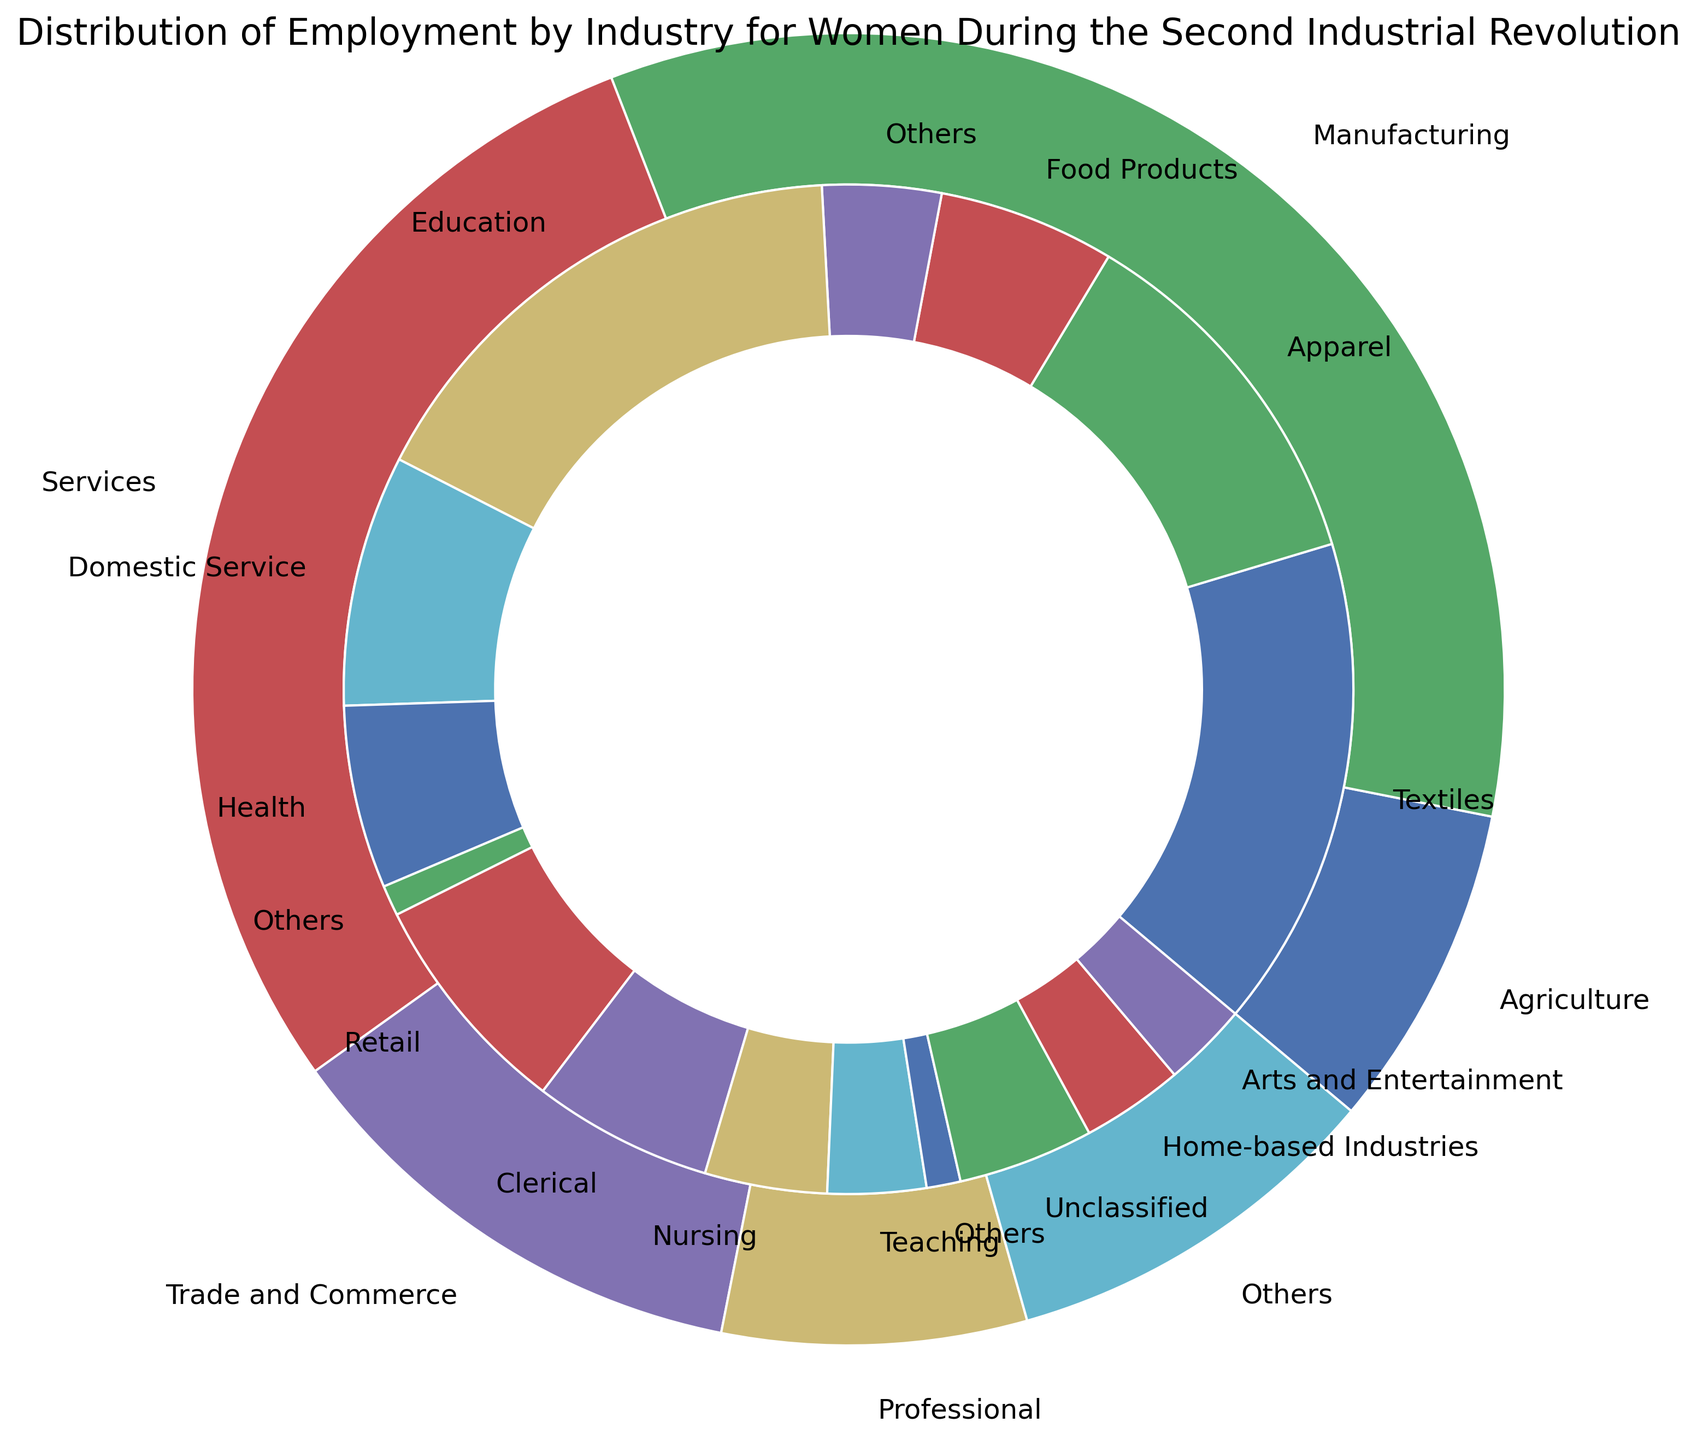What percentage of women were employed in the Services industry? The Services sector is represented as a main part of the outer pie segment, and its label indicates a 29% share of employment.
Answer: 29% Which sub-industry within Manufacturing employs the highest percentage of women? The sub-industries within Manufacturing are represented in the inner pie segment. Among Textiles, Apparel, Food Products, and Others, Textiles has the highest percentage of 14.5%.
Answer: Textiles What is the combined percentage of women employed in the Education and Health sub-industries within Services? From the inner pie segment, Education employs 15.3% and Health employs 5.4%. Adding these percentages gives 15.3 + 5.4 = 20.7%.
Answer: 20.7% Which has a higher percentage of employment, Agriculture or Trade and Commerce? Both Agriculture and Trade and Commerce are main industries shown in the outer pie. Agriculture has 8% while Trade and Commerce has 12%. Therefore, Trade and Commerce has a higher percentage.
Answer: Trade and Commerce What is the total percentage of women employed in the Manufacturing sub-industries, excluding 'Others'? The sub-industries of Manufacturing are Textiles (14.5%), Apparel (10.8%), and Food Products (5.2%). The total is 14.5 + 10.8 + 5.2 = 30.5%.
Answer: 30.5% How does the percentage of women in Domestic Service compare to that in Nursing? Domestic Service within the Services sector employs 7.4%, and Nursing within the Professional sector employs 3.6%. Domestic Service has a higher percentage.
Answer: Domestic Service has a higher percentage Which main industry employs more women, Professional or Others? The outer pie shows the percentage for Professional (7.5%) and Others (9.5%). Others employs more women.
Answer: Others What percentage of employment is attributed to sub-industries within Trade and Commerce? The sub-industries within Trade and Commerce are Retail (6.7%) and Clerical (5.3%). Adding these percentages gives 6.7 + 5.3 = 12%.
Answer: 12% What is the difference in percentage between women employed in Home-based Industries and Arts and Entertainment? Home-based Industries within Others has 3.0%, and Arts and Entertainment within Others has 2.5%. The difference is 3.0 - 2.5 = 0.5%.
Answer: 0.5% How many sub-industries have a higher percentage of employment than Agriculture? Agriculture employs 8%. The sub-industries with higher percentages are Textiles (14.5%), Apparel (10.8%), and Education (15.3%). Hence, there are three sub-industries.
Answer: 3 